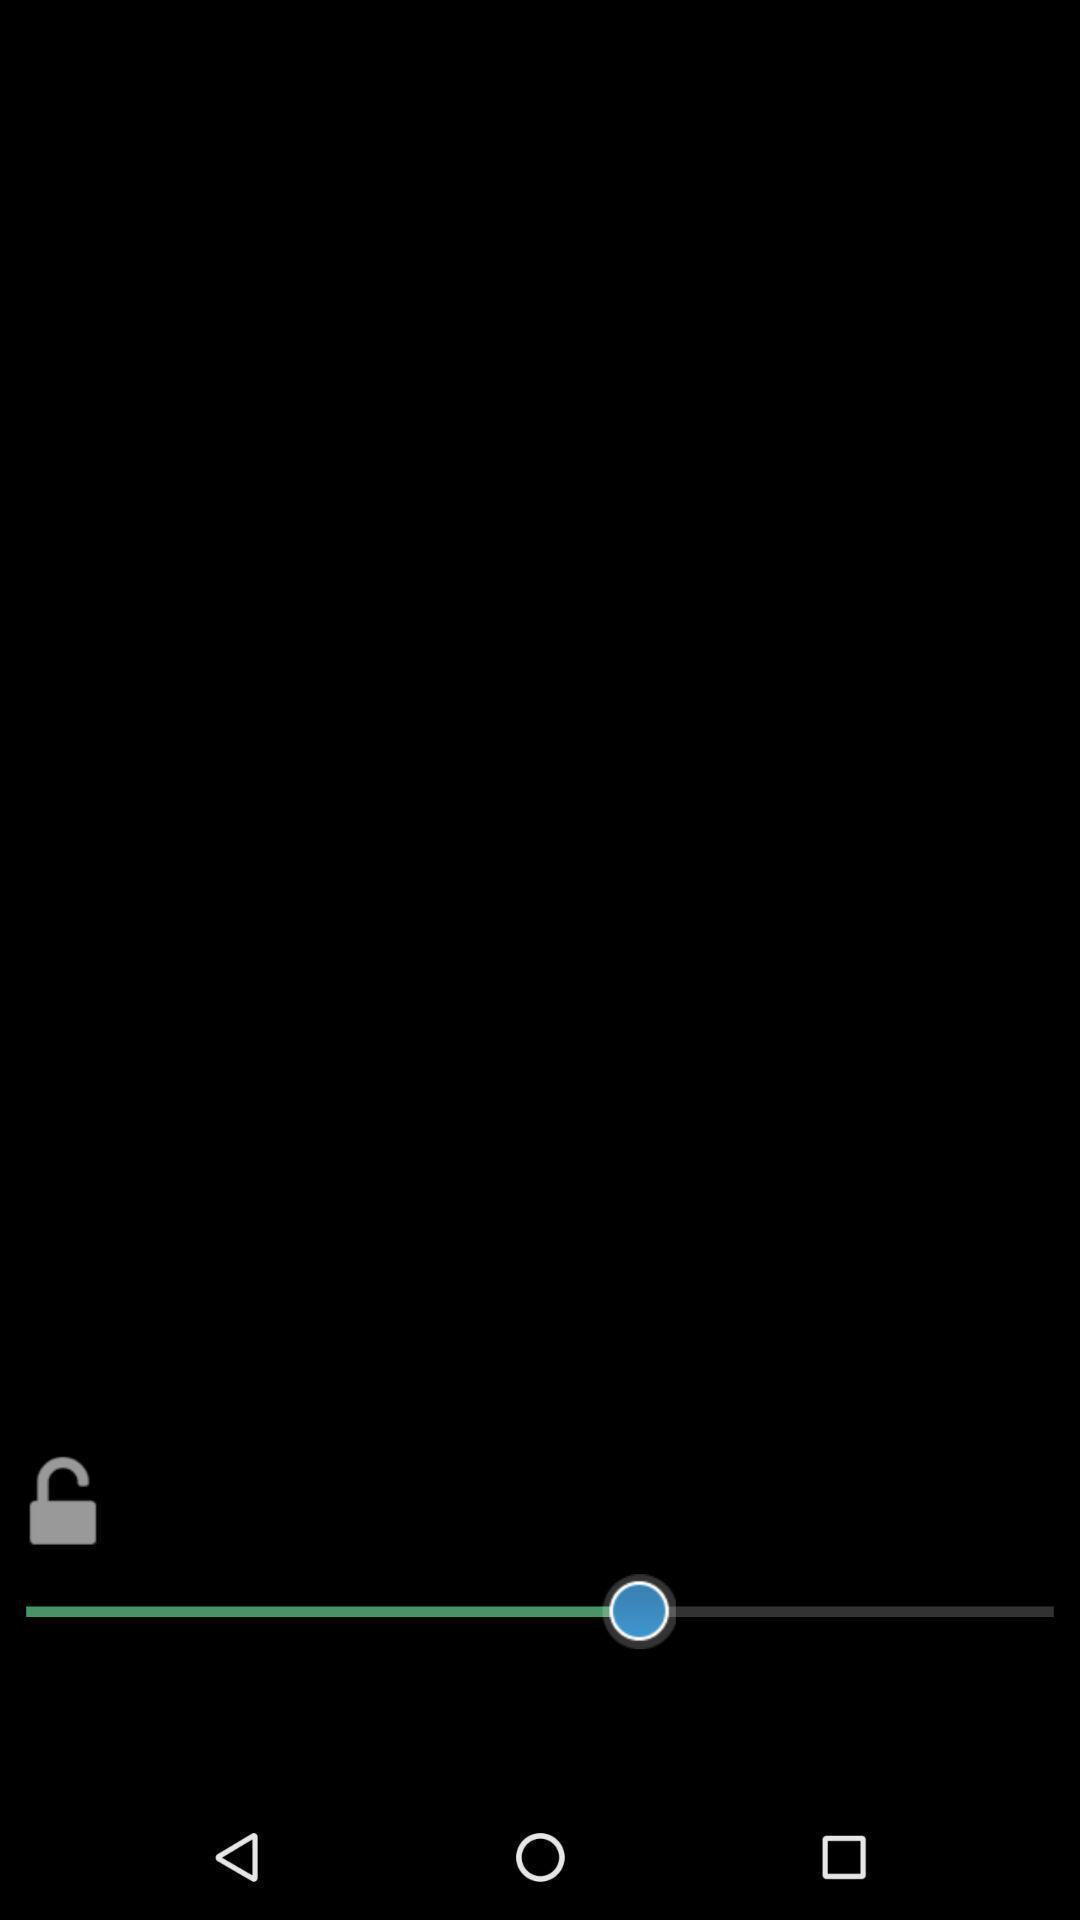Provide a textual representation of this image. Screen displaying adjustment of brightness. 